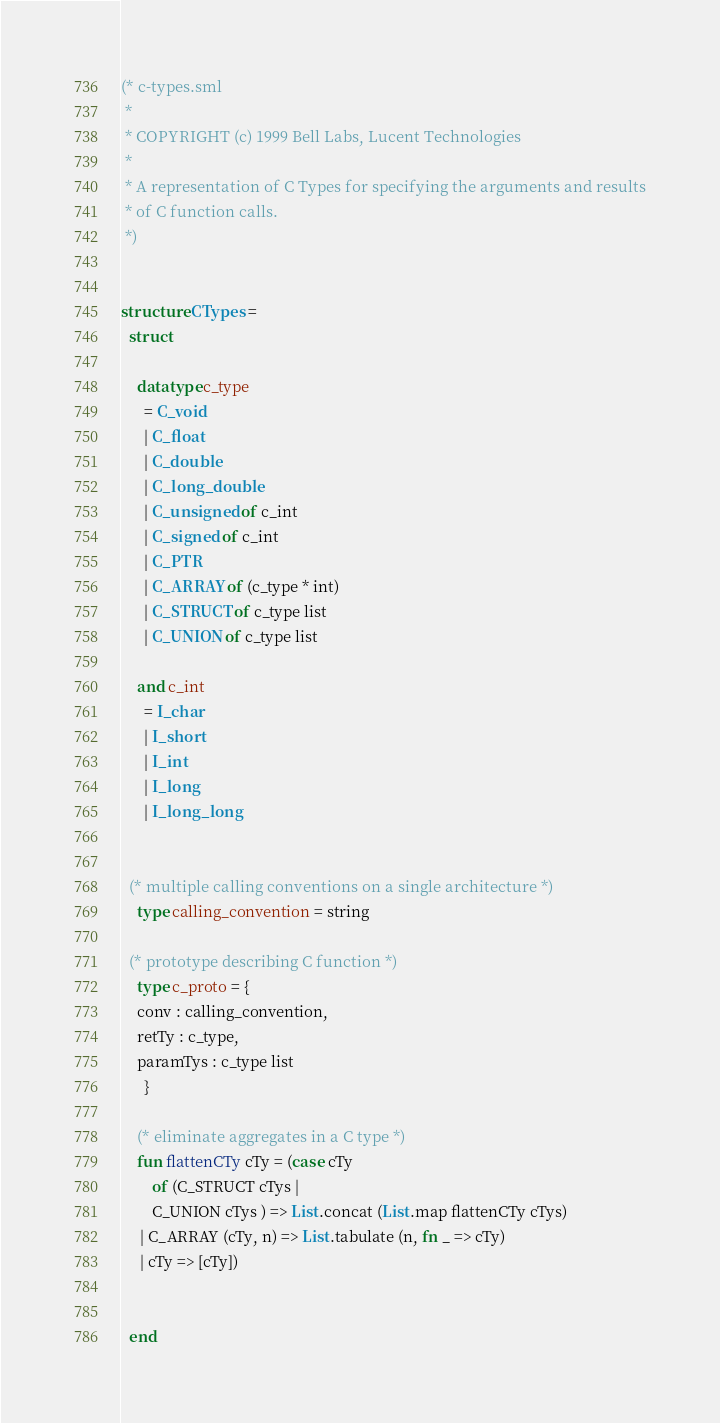<code> <loc_0><loc_0><loc_500><loc_500><_SML_>(* c-types.sml
 *
 * COPYRIGHT (c) 1999 Bell Labs, Lucent Technologies
 *
 * A representation of C Types for specifying the arguments and results
 * of C function calls.
 *)


structure CTypes =
  struct

    datatype c_type
      = C_void
      | C_float
      | C_double
      | C_long_double
      | C_unsigned of c_int
      | C_signed of c_int
      | C_PTR
      | C_ARRAY of (c_type * int)
      | C_STRUCT of c_type list
      | C_UNION of c_type list

    and c_int
      = I_char
      | I_short
      | I_int
      | I_long
      | I_long_long


  (* multiple calling conventions on a single architecture *)
    type calling_convention = string

  (* prototype describing C function *)
    type c_proto = {
	conv : calling_convention,
	retTy : c_type,
	paramTys : c_type list
      }

    (* eliminate aggregates in a C type *)
    fun flattenCTy cTy = (case cTy
        of (C_STRUCT cTys |
	    C_UNION cTys ) => List.concat (List.map flattenCTy cTys)
	 | C_ARRAY (cTy, n) => List.tabulate (n, fn _ => cTy)
	 | cTy => [cTy])


  end
</code> 